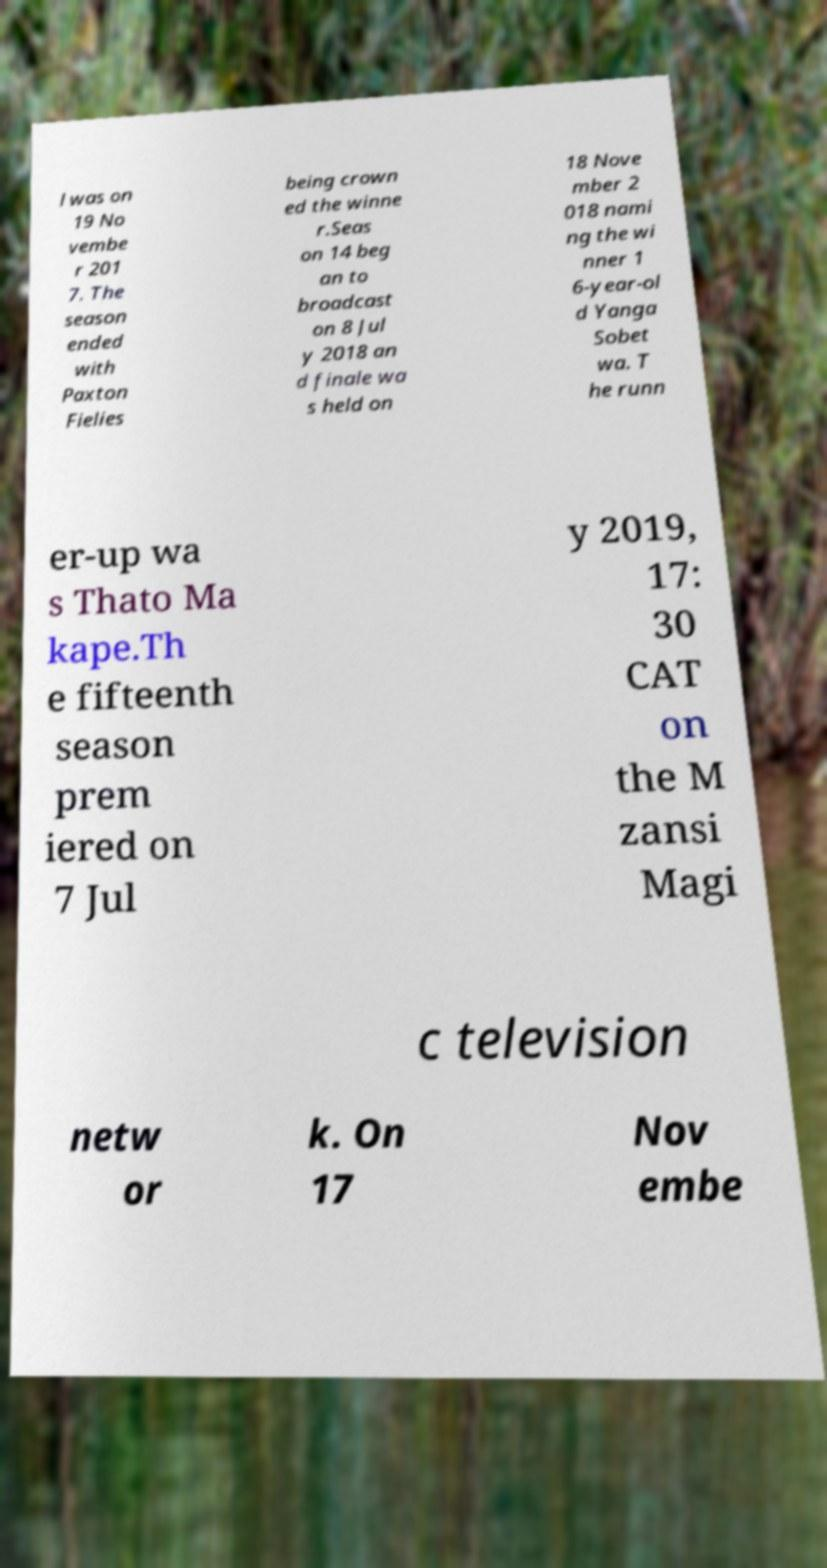Please identify and transcribe the text found in this image. l was on 19 No vembe r 201 7. The season ended with Paxton Fielies being crown ed the winne r.Seas on 14 beg an to broadcast on 8 Jul y 2018 an d finale wa s held on 18 Nove mber 2 018 nami ng the wi nner 1 6-year-ol d Yanga Sobet wa. T he runn er-up wa s Thato Ma kape.Th e fifteenth season prem iered on 7 Jul y 2019, 17: 30 CAT on the M zansi Magi c television netw or k. On 17 Nov embe 